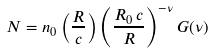Convert formula to latex. <formula><loc_0><loc_0><loc_500><loc_500>N = n _ { 0 } \left ( \frac { R } { c } \right ) \left ( \frac { R _ { 0 } \, c } { R } \right ) ^ { - \nu } G ( \nu )</formula> 